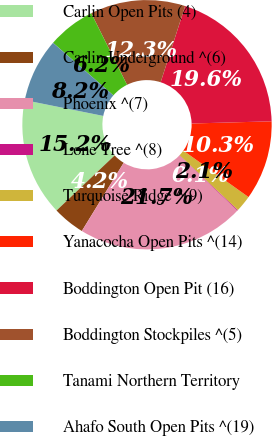<chart> <loc_0><loc_0><loc_500><loc_500><pie_chart><fcel>Carlin Open Pits (4)<fcel>Carlin Underground ^(6)<fcel>Phoenix ^(7)<fcel>Lone Tree ^(8)<fcel>Turquoise Ridge ^(9)<fcel>Yanacocha Open Pits ^(14)<fcel>Boddington Open Pit (16)<fcel>Boddington Stockpiles ^(5)<fcel>Tanami Northern Territory<fcel>Ahafo South Open Pits ^(19)<nl><fcel>15.24%<fcel>4.17%<fcel>21.66%<fcel>0.1%<fcel>2.14%<fcel>10.29%<fcel>19.62%<fcel>12.33%<fcel>6.21%<fcel>8.25%<nl></chart> 